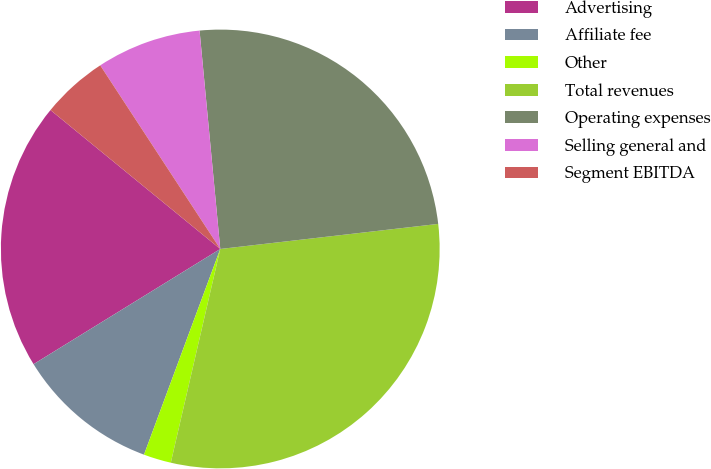Convert chart. <chart><loc_0><loc_0><loc_500><loc_500><pie_chart><fcel>Advertising<fcel>Affiliate fee<fcel>Other<fcel>Total revenues<fcel>Operating expenses<fcel>Selling general and<fcel>Segment EBITDA<nl><fcel>19.71%<fcel>10.55%<fcel>2.03%<fcel>30.44%<fcel>24.68%<fcel>7.71%<fcel>4.87%<nl></chart> 